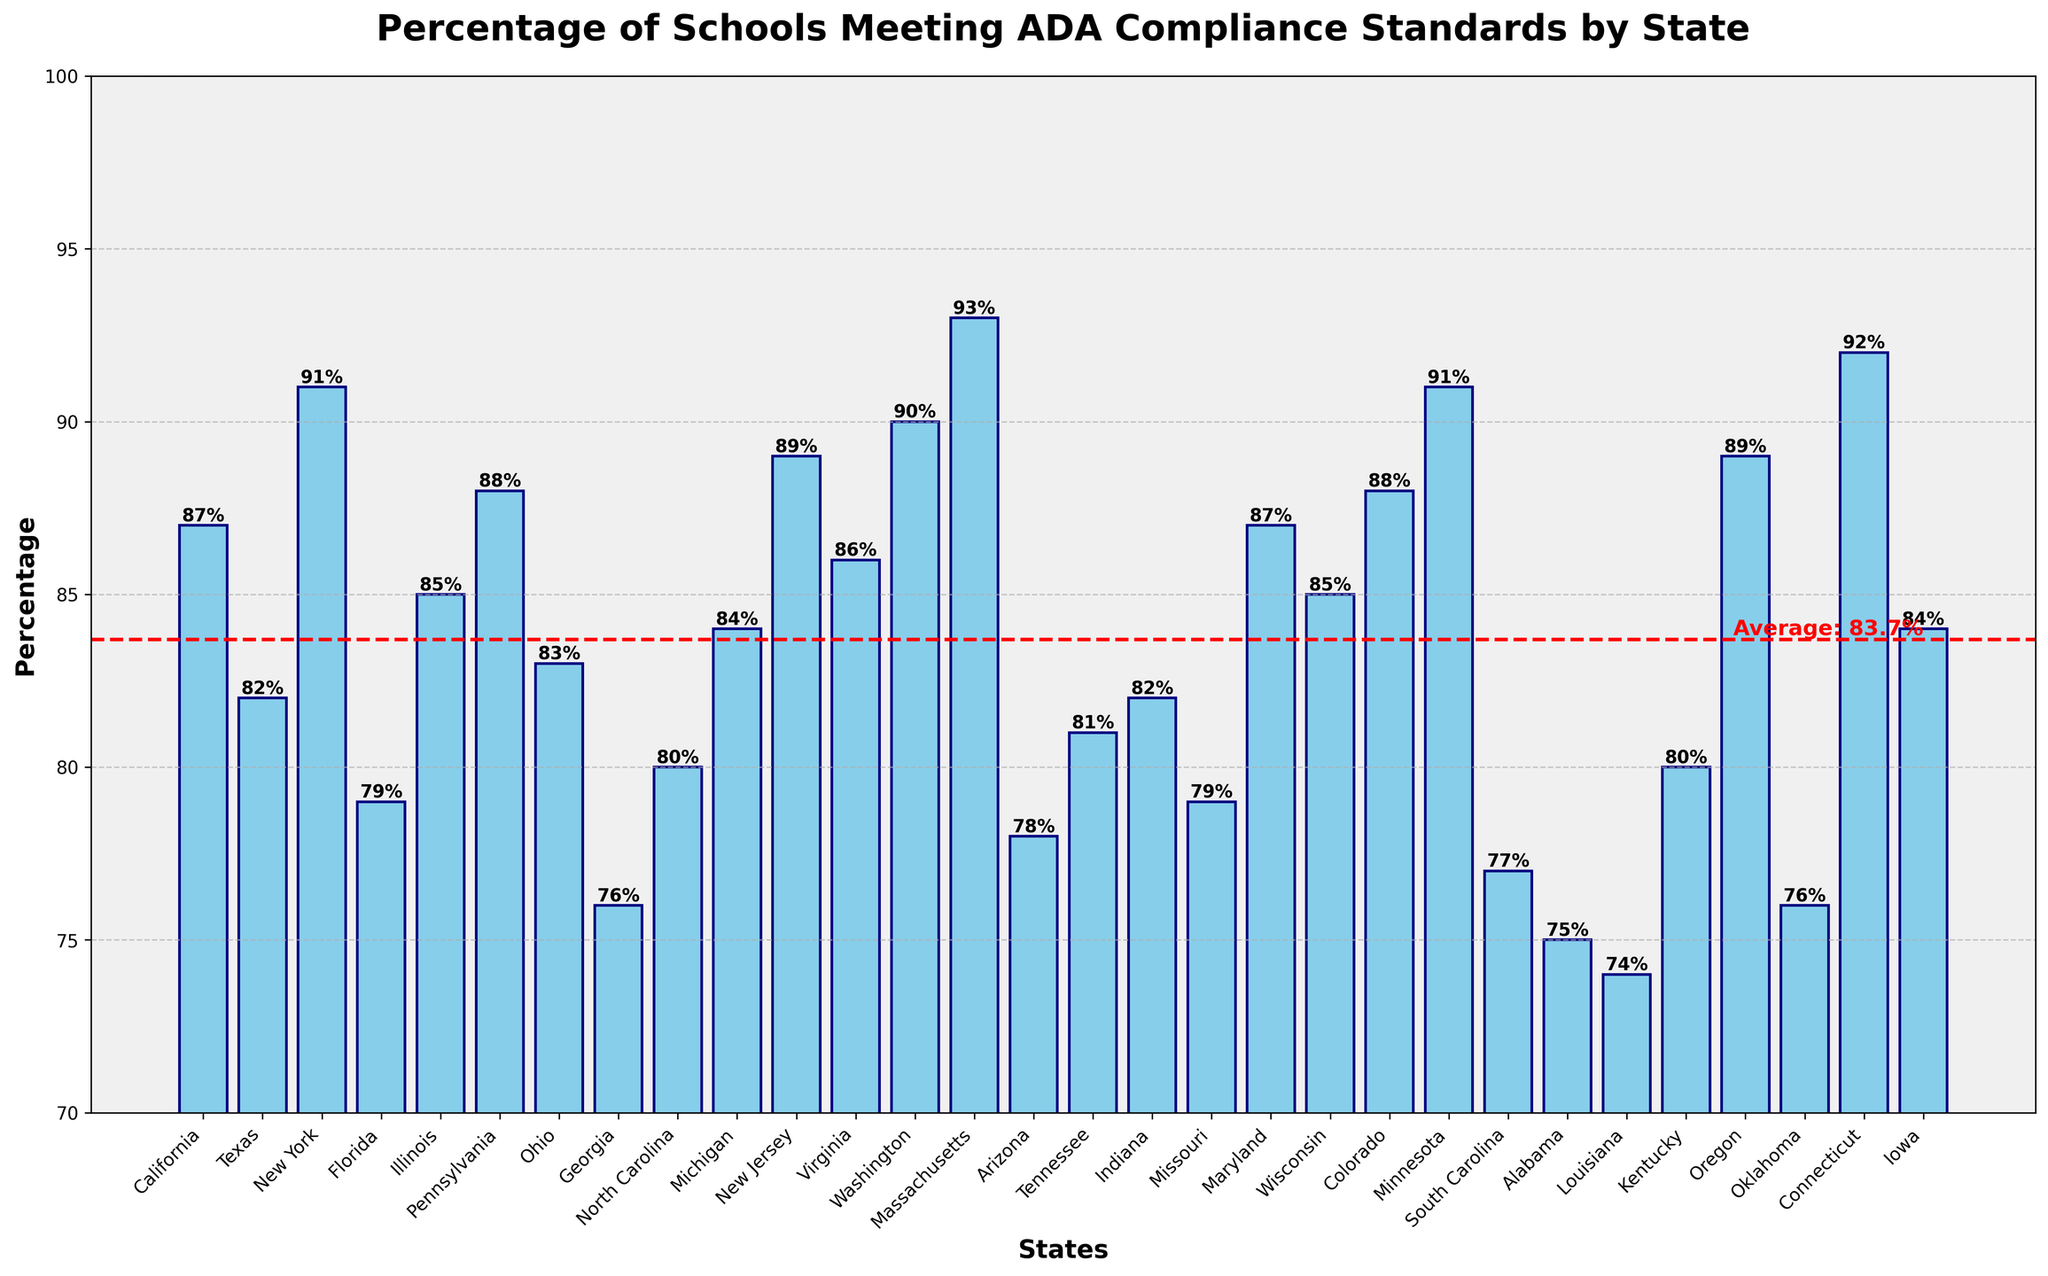What state has the highest percentage of schools meeting ADA compliance standards? Look at the state with the tallest bar in the chart. Massachusetts has the tallest bar.
Answer: Massachusetts What state has the lowest percentage of schools meeting ADA compliance standards? Look at the state with the shortest bar in the chart. Louisiana has the shortest bar.
Answer: Louisiana Which states have a percentage of schools meeting ADA compliance standards above 90%? Look for states with bars extending above the 90% mark. New York, Massachusetts, Minnesota, and Connecticut all have bars that extend above 90%.
Answer: New York, Massachusetts, Minnesota, Connecticut How many states have a percentage of schools meeting ADA compliance standards below the average? First, identify the average line (around 84.1%). Count the bars that are below this line. There are 13 states with percentages below the average.
Answer: 13 states What is the percentage difference between the state with the highest compliance and the state with the lowest compliance? Subtract the percentage of the lowest compliance state (Louisiana, 74%) from the percentage of the highest compliance state (Massachusetts, 93%). The difference is 93% - 74% = 19%.
Answer: 19% Which states have their compliance percentage closest to the average percentage indicated by the red line? Identify the states with bar heights closest to the average line (around 84.1%). The states closest are Michigan (84%) and Iowa (84%).
Answer: Michigan, Iowa Compare the compliance percentage of northern states (like New York) with southern states (like Alabama). What do you observe? Look at the bars for states known to be in the northern U.S. (e.g., New York, Massachusetts) and compare them with bars for southern states (e.g., Alabama, Georgia). Northern states generally have higher compliance percentages compared to southern states.
Answer: Northern states generally higher How many states have a compliance percentage in the 80-85% range? Count the number of bars that fall within the 80% to 85% range. There are 7 states (Texas, Ohio, Indiana, Michigan, Kentucky, Iowa, and Tennessee).
Answer: 7 states Which states have bars that reach exactly the average compliance percentage line? Identify which bars exactly intersect the average compliance line (around 84.1%). None of the states' bars exactly intersect the average line.
Answer: None What is the percentage of Georgia compared to the overall average? Is it higher or lower? Compare Georgia's percentage (76%) to the average (84.1%). Georgia's percentage is lower than the average.
Answer: Lower 